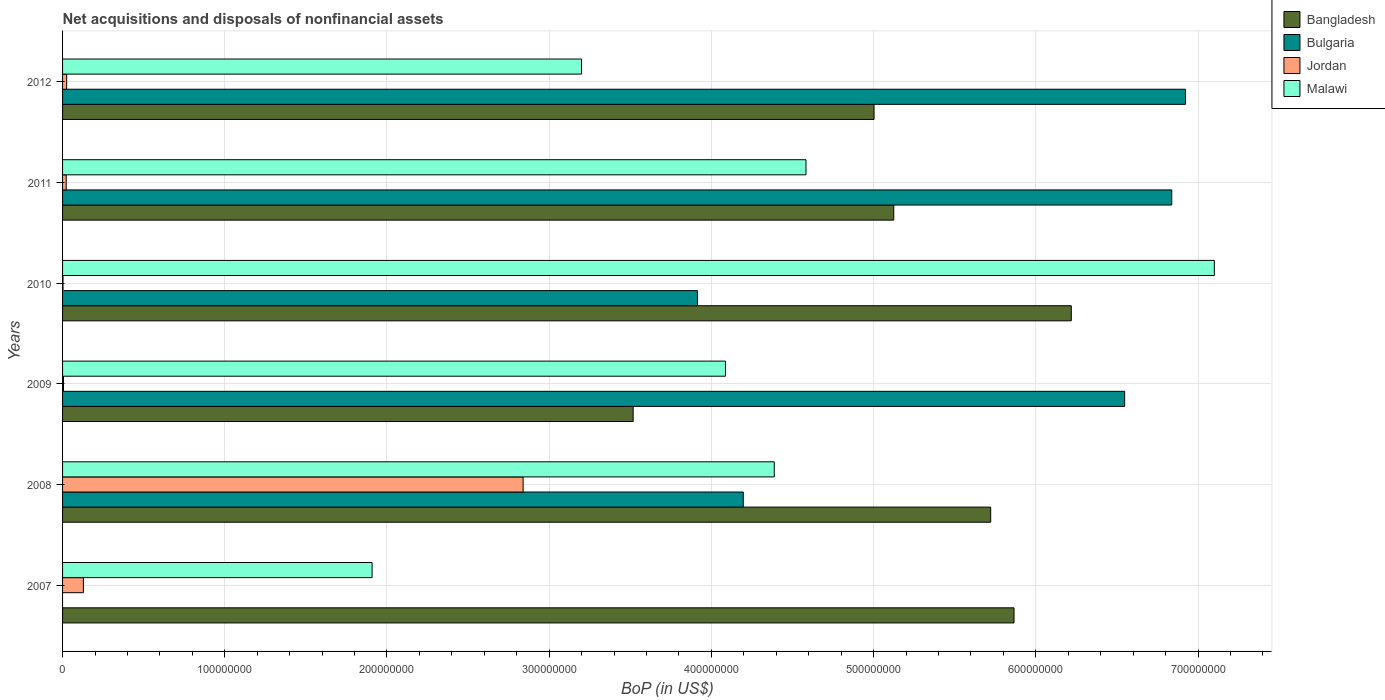How many groups of bars are there?
Your answer should be compact. 6. Are the number of bars per tick equal to the number of legend labels?
Make the answer very short. No. How many bars are there on the 3rd tick from the bottom?
Provide a short and direct response. 4. What is the label of the 5th group of bars from the top?
Offer a terse response. 2008. What is the Balance of Payments in Jordan in 2011?
Provide a short and direct response. 2.25e+06. Across all years, what is the maximum Balance of Payments in Jordan?
Your answer should be compact. 2.84e+08. Across all years, what is the minimum Balance of Payments in Bangladesh?
Your answer should be very brief. 3.52e+08. What is the total Balance of Payments in Bangladesh in the graph?
Your response must be concise. 3.15e+09. What is the difference between the Balance of Payments in Jordan in 2007 and that in 2012?
Offer a terse response. 1.03e+07. What is the difference between the Balance of Payments in Malawi in 2010 and the Balance of Payments in Jordan in 2008?
Provide a short and direct response. 4.26e+08. What is the average Balance of Payments in Bangladesh per year?
Your answer should be compact. 5.24e+08. In the year 2011, what is the difference between the Balance of Payments in Malawi and Balance of Payments in Bangladesh?
Ensure brevity in your answer.  -5.41e+07. What is the ratio of the Balance of Payments in Malawi in 2007 to that in 2011?
Offer a very short reply. 0.42. Is the difference between the Balance of Payments in Malawi in 2007 and 2008 greater than the difference between the Balance of Payments in Bangladesh in 2007 and 2008?
Ensure brevity in your answer.  No. What is the difference between the highest and the second highest Balance of Payments in Malawi?
Make the answer very short. 2.52e+08. What is the difference between the highest and the lowest Balance of Payments in Bulgaria?
Make the answer very short. 6.92e+08. Is it the case that in every year, the sum of the Balance of Payments in Bulgaria and Balance of Payments in Malawi is greater than the Balance of Payments in Jordan?
Make the answer very short. Yes. How many bars are there?
Ensure brevity in your answer.  23. What is the difference between two consecutive major ticks on the X-axis?
Provide a short and direct response. 1.00e+08. Does the graph contain any zero values?
Keep it short and to the point. Yes. Does the graph contain grids?
Make the answer very short. Yes. Where does the legend appear in the graph?
Make the answer very short. Top right. How are the legend labels stacked?
Make the answer very short. Vertical. What is the title of the graph?
Offer a terse response. Net acquisitions and disposals of nonfinancial assets. Does "Slovenia" appear as one of the legend labels in the graph?
Your response must be concise. No. What is the label or title of the X-axis?
Keep it short and to the point. BoP (in US$). What is the BoP (in US$) of Bangladesh in 2007?
Offer a very short reply. 5.87e+08. What is the BoP (in US$) of Jordan in 2007?
Your answer should be compact. 1.28e+07. What is the BoP (in US$) in Malawi in 2007?
Make the answer very short. 1.91e+08. What is the BoP (in US$) of Bangladesh in 2008?
Your answer should be compact. 5.72e+08. What is the BoP (in US$) in Bulgaria in 2008?
Your answer should be very brief. 4.20e+08. What is the BoP (in US$) of Jordan in 2008?
Your response must be concise. 2.84e+08. What is the BoP (in US$) of Malawi in 2008?
Your answer should be very brief. 4.39e+08. What is the BoP (in US$) in Bangladesh in 2009?
Ensure brevity in your answer.  3.52e+08. What is the BoP (in US$) of Bulgaria in 2009?
Make the answer very short. 6.55e+08. What is the BoP (in US$) of Jordan in 2009?
Make the answer very short. 5.63e+05. What is the BoP (in US$) of Malawi in 2009?
Keep it short and to the point. 4.09e+08. What is the BoP (in US$) of Bangladesh in 2010?
Your answer should be compact. 6.22e+08. What is the BoP (in US$) in Bulgaria in 2010?
Your response must be concise. 3.91e+08. What is the BoP (in US$) in Jordan in 2010?
Provide a succinct answer. 2.82e+05. What is the BoP (in US$) in Malawi in 2010?
Keep it short and to the point. 7.10e+08. What is the BoP (in US$) in Bangladesh in 2011?
Keep it short and to the point. 5.12e+08. What is the BoP (in US$) of Bulgaria in 2011?
Your answer should be compact. 6.84e+08. What is the BoP (in US$) of Jordan in 2011?
Give a very brief answer. 2.25e+06. What is the BoP (in US$) in Malawi in 2011?
Provide a succinct answer. 4.58e+08. What is the BoP (in US$) of Bangladesh in 2012?
Your answer should be compact. 5.00e+08. What is the BoP (in US$) of Bulgaria in 2012?
Your answer should be compact. 6.92e+08. What is the BoP (in US$) of Jordan in 2012?
Offer a terse response. 2.54e+06. What is the BoP (in US$) of Malawi in 2012?
Make the answer very short. 3.20e+08. Across all years, what is the maximum BoP (in US$) of Bangladesh?
Make the answer very short. 6.22e+08. Across all years, what is the maximum BoP (in US$) in Bulgaria?
Your answer should be very brief. 6.92e+08. Across all years, what is the maximum BoP (in US$) in Jordan?
Offer a terse response. 2.84e+08. Across all years, what is the maximum BoP (in US$) of Malawi?
Offer a terse response. 7.10e+08. Across all years, what is the minimum BoP (in US$) of Bangladesh?
Ensure brevity in your answer.  3.52e+08. Across all years, what is the minimum BoP (in US$) in Bulgaria?
Your answer should be compact. 0. Across all years, what is the minimum BoP (in US$) of Jordan?
Your answer should be compact. 2.82e+05. Across all years, what is the minimum BoP (in US$) in Malawi?
Give a very brief answer. 1.91e+08. What is the total BoP (in US$) of Bangladesh in the graph?
Keep it short and to the point. 3.15e+09. What is the total BoP (in US$) of Bulgaria in the graph?
Your answer should be compact. 2.84e+09. What is the total BoP (in US$) in Jordan in the graph?
Ensure brevity in your answer.  3.02e+08. What is the total BoP (in US$) in Malawi in the graph?
Provide a succinct answer. 2.53e+09. What is the difference between the BoP (in US$) of Bangladesh in 2007 and that in 2008?
Provide a short and direct response. 1.44e+07. What is the difference between the BoP (in US$) in Jordan in 2007 and that in 2008?
Ensure brevity in your answer.  -2.71e+08. What is the difference between the BoP (in US$) in Malawi in 2007 and that in 2008?
Offer a terse response. -2.48e+08. What is the difference between the BoP (in US$) of Bangladesh in 2007 and that in 2009?
Make the answer very short. 2.35e+08. What is the difference between the BoP (in US$) of Jordan in 2007 and that in 2009?
Provide a succinct answer. 1.23e+07. What is the difference between the BoP (in US$) in Malawi in 2007 and that in 2009?
Provide a short and direct response. -2.18e+08. What is the difference between the BoP (in US$) of Bangladesh in 2007 and that in 2010?
Provide a succinct answer. -3.53e+07. What is the difference between the BoP (in US$) in Jordan in 2007 and that in 2010?
Your answer should be compact. 1.26e+07. What is the difference between the BoP (in US$) of Malawi in 2007 and that in 2010?
Provide a succinct answer. -5.19e+08. What is the difference between the BoP (in US$) of Bangladesh in 2007 and that in 2011?
Provide a short and direct response. 7.41e+07. What is the difference between the BoP (in US$) of Jordan in 2007 and that in 2011?
Keep it short and to the point. 1.06e+07. What is the difference between the BoP (in US$) of Malawi in 2007 and that in 2011?
Your answer should be compact. -2.67e+08. What is the difference between the BoP (in US$) of Bangladesh in 2007 and that in 2012?
Keep it short and to the point. 8.63e+07. What is the difference between the BoP (in US$) in Jordan in 2007 and that in 2012?
Your answer should be very brief. 1.03e+07. What is the difference between the BoP (in US$) of Malawi in 2007 and that in 2012?
Offer a terse response. -1.29e+08. What is the difference between the BoP (in US$) of Bangladesh in 2008 and that in 2009?
Your response must be concise. 2.20e+08. What is the difference between the BoP (in US$) of Bulgaria in 2008 and that in 2009?
Keep it short and to the point. -2.35e+08. What is the difference between the BoP (in US$) in Jordan in 2008 and that in 2009?
Make the answer very short. 2.83e+08. What is the difference between the BoP (in US$) of Malawi in 2008 and that in 2009?
Offer a very short reply. 3.01e+07. What is the difference between the BoP (in US$) of Bangladesh in 2008 and that in 2010?
Keep it short and to the point. -4.97e+07. What is the difference between the BoP (in US$) of Bulgaria in 2008 and that in 2010?
Your response must be concise. 2.82e+07. What is the difference between the BoP (in US$) in Jordan in 2008 and that in 2010?
Offer a very short reply. 2.84e+08. What is the difference between the BoP (in US$) in Malawi in 2008 and that in 2010?
Make the answer very short. -2.71e+08. What is the difference between the BoP (in US$) of Bangladesh in 2008 and that in 2011?
Provide a succinct answer. 5.98e+07. What is the difference between the BoP (in US$) in Bulgaria in 2008 and that in 2011?
Offer a terse response. -2.64e+08. What is the difference between the BoP (in US$) of Jordan in 2008 and that in 2011?
Provide a succinct answer. 2.82e+08. What is the difference between the BoP (in US$) of Malawi in 2008 and that in 2011?
Keep it short and to the point. -1.96e+07. What is the difference between the BoP (in US$) in Bangladesh in 2008 and that in 2012?
Your answer should be compact. 7.19e+07. What is the difference between the BoP (in US$) in Bulgaria in 2008 and that in 2012?
Your answer should be very brief. -2.73e+08. What is the difference between the BoP (in US$) of Jordan in 2008 and that in 2012?
Make the answer very short. 2.81e+08. What is the difference between the BoP (in US$) in Malawi in 2008 and that in 2012?
Provide a succinct answer. 1.19e+08. What is the difference between the BoP (in US$) in Bangladesh in 2009 and that in 2010?
Ensure brevity in your answer.  -2.70e+08. What is the difference between the BoP (in US$) of Bulgaria in 2009 and that in 2010?
Ensure brevity in your answer.  2.63e+08. What is the difference between the BoP (in US$) in Jordan in 2009 and that in 2010?
Your answer should be very brief. 2.82e+05. What is the difference between the BoP (in US$) of Malawi in 2009 and that in 2010?
Ensure brevity in your answer.  -3.01e+08. What is the difference between the BoP (in US$) of Bangladesh in 2009 and that in 2011?
Your answer should be compact. -1.61e+08. What is the difference between the BoP (in US$) of Bulgaria in 2009 and that in 2011?
Provide a succinct answer. -2.90e+07. What is the difference between the BoP (in US$) of Jordan in 2009 and that in 2011?
Give a very brief answer. -1.69e+06. What is the difference between the BoP (in US$) of Malawi in 2009 and that in 2011?
Provide a succinct answer. -4.96e+07. What is the difference between the BoP (in US$) of Bangladesh in 2009 and that in 2012?
Your answer should be compact. -1.48e+08. What is the difference between the BoP (in US$) of Bulgaria in 2009 and that in 2012?
Your answer should be very brief. -3.75e+07. What is the difference between the BoP (in US$) in Jordan in 2009 and that in 2012?
Your response must be concise. -1.97e+06. What is the difference between the BoP (in US$) of Malawi in 2009 and that in 2012?
Make the answer very short. 8.88e+07. What is the difference between the BoP (in US$) of Bangladesh in 2010 and that in 2011?
Ensure brevity in your answer.  1.09e+08. What is the difference between the BoP (in US$) in Bulgaria in 2010 and that in 2011?
Give a very brief answer. -2.92e+08. What is the difference between the BoP (in US$) in Jordan in 2010 and that in 2011?
Offer a very short reply. -1.97e+06. What is the difference between the BoP (in US$) of Malawi in 2010 and that in 2011?
Make the answer very short. 2.52e+08. What is the difference between the BoP (in US$) of Bangladesh in 2010 and that in 2012?
Offer a terse response. 1.22e+08. What is the difference between the BoP (in US$) in Bulgaria in 2010 and that in 2012?
Your response must be concise. -3.01e+08. What is the difference between the BoP (in US$) in Jordan in 2010 and that in 2012?
Offer a very short reply. -2.25e+06. What is the difference between the BoP (in US$) of Malawi in 2010 and that in 2012?
Ensure brevity in your answer.  3.90e+08. What is the difference between the BoP (in US$) of Bangladesh in 2011 and that in 2012?
Give a very brief answer. 1.21e+07. What is the difference between the BoP (in US$) of Bulgaria in 2011 and that in 2012?
Provide a short and direct response. -8.50e+06. What is the difference between the BoP (in US$) in Jordan in 2011 and that in 2012?
Ensure brevity in your answer.  -2.82e+05. What is the difference between the BoP (in US$) of Malawi in 2011 and that in 2012?
Give a very brief answer. 1.38e+08. What is the difference between the BoP (in US$) of Bangladesh in 2007 and the BoP (in US$) of Bulgaria in 2008?
Your answer should be very brief. 1.67e+08. What is the difference between the BoP (in US$) of Bangladesh in 2007 and the BoP (in US$) of Jordan in 2008?
Your answer should be very brief. 3.03e+08. What is the difference between the BoP (in US$) in Bangladesh in 2007 and the BoP (in US$) in Malawi in 2008?
Keep it short and to the point. 1.48e+08. What is the difference between the BoP (in US$) of Jordan in 2007 and the BoP (in US$) of Malawi in 2008?
Offer a very short reply. -4.26e+08. What is the difference between the BoP (in US$) in Bangladesh in 2007 and the BoP (in US$) in Bulgaria in 2009?
Provide a short and direct response. -6.82e+07. What is the difference between the BoP (in US$) in Bangladesh in 2007 and the BoP (in US$) in Jordan in 2009?
Your response must be concise. 5.86e+08. What is the difference between the BoP (in US$) of Bangladesh in 2007 and the BoP (in US$) of Malawi in 2009?
Your response must be concise. 1.78e+08. What is the difference between the BoP (in US$) in Jordan in 2007 and the BoP (in US$) in Malawi in 2009?
Your answer should be compact. -3.96e+08. What is the difference between the BoP (in US$) in Bangladesh in 2007 and the BoP (in US$) in Bulgaria in 2010?
Your answer should be compact. 1.95e+08. What is the difference between the BoP (in US$) in Bangladesh in 2007 and the BoP (in US$) in Jordan in 2010?
Offer a very short reply. 5.86e+08. What is the difference between the BoP (in US$) of Bangladesh in 2007 and the BoP (in US$) of Malawi in 2010?
Make the answer very short. -1.23e+08. What is the difference between the BoP (in US$) in Jordan in 2007 and the BoP (in US$) in Malawi in 2010?
Make the answer very short. -6.97e+08. What is the difference between the BoP (in US$) in Bangladesh in 2007 and the BoP (in US$) in Bulgaria in 2011?
Give a very brief answer. -9.72e+07. What is the difference between the BoP (in US$) in Bangladesh in 2007 and the BoP (in US$) in Jordan in 2011?
Keep it short and to the point. 5.84e+08. What is the difference between the BoP (in US$) of Bangladesh in 2007 and the BoP (in US$) of Malawi in 2011?
Offer a terse response. 1.28e+08. What is the difference between the BoP (in US$) in Jordan in 2007 and the BoP (in US$) in Malawi in 2011?
Provide a short and direct response. -4.45e+08. What is the difference between the BoP (in US$) in Bangladesh in 2007 and the BoP (in US$) in Bulgaria in 2012?
Ensure brevity in your answer.  -1.06e+08. What is the difference between the BoP (in US$) of Bangladesh in 2007 and the BoP (in US$) of Jordan in 2012?
Offer a terse response. 5.84e+08. What is the difference between the BoP (in US$) of Bangladesh in 2007 and the BoP (in US$) of Malawi in 2012?
Ensure brevity in your answer.  2.67e+08. What is the difference between the BoP (in US$) of Jordan in 2007 and the BoP (in US$) of Malawi in 2012?
Your answer should be compact. -3.07e+08. What is the difference between the BoP (in US$) in Bangladesh in 2008 and the BoP (in US$) in Bulgaria in 2009?
Offer a terse response. -8.26e+07. What is the difference between the BoP (in US$) in Bangladesh in 2008 and the BoP (in US$) in Jordan in 2009?
Your answer should be very brief. 5.72e+08. What is the difference between the BoP (in US$) of Bangladesh in 2008 and the BoP (in US$) of Malawi in 2009?
Offer a terse response. 1.63e+08. What is the difference between the BoP (in US$) of Bulgaria in 2008 and the BoP (in US$) of Jordan in 2009?
Offer a very short reply. 4.19e+08. What is the difference between the BoP (in US$) of Bulgaria in 2008 and the BoP (in US$) of Malawi in 2009?
Keep it short and to the point. 1.10e+07. What is the difference between the BoP (in US$) in Jordan in 2008 and the BoP (in US$) in Malawi in 2009?
Your response must be concise. -1.25e+08. What is the difference between the BoP (in US$) in Bangladesh in 2008 and the BoP (in US$) in Bulgaria in 2010?
Give a very brief answer. 1.81e+08. What is the difference between the BoP (in US$) in Bangladesh in 2008 and the BoP (in US$) in Jordan in 2010?
Offer a very short reply. 5.72e+08. What is the difference between the BoP (in US$) in Bangladesh in 2008 and the BoP (in US$) in Malawi in 2010?
Your answer should be compact. -1.38e+08. What is the difference between the BoP (in US$) of Bulgaria in 2008 and the BoP (in US$) of Jordan in 2010?
Keep it short and to the point. 4.19e+08. What is the difference between the BoP (in US$) of Bulgaria in 2008 and the BoP (in US$) of Malawi in 2010?
Your answer should be compact. -2.90e+08. What is the difference between the BoP (in US$) in Jordan in 2008 and the BoP (in US$) in Malawi in 2010?
Your answer should be very brief. -4.26e+08. What is the difference between the BoP (in US$) of Bangladesh in 2008 and the BoP (in US$) of Bulgaria in 2011?
Your answer should be compact. -1.12e+08. What is the difference between the BoP (in US$) in Bangladesh in 2008 and the BoP (in US$) in Jordan in 2011?
Make the answer very short. 5.70e+08. What is the difference between the BoP (in US$) of Bangladesh in 2008 and the BoP (in US$) of Malawi in 2011?
Ensure brevity in your answer.  1.14e+08. What is the difference between the BoP (in US$) of Bulgaria in 2008 and the BoP (in US$) of Jordan in 2011?
Offer a very short reply. 4.17e+08. What is the difference between the BoP (in US$) of Bulgaria in 2008 and the BoP (in US$) of Malawi in 2011?
Ensure brevity in your answer.  -3.87e+07. What is the difference between the BoP (in US$) in Jordan in 2008 and the BoP (in US$) in Malawi in 2011?
Your answer should be very brief. -1.74e+08. What is the difference between the BoP (in US$) in Bangladesh in 2008 and the BoP (in US$) in Bulgaria in 2012?
Offer a very short reply. -1.20e+08. What is the difference between the BoP (in US$) in Bangladesh in 2008 and the BoP (in US$) in Jordan in 2012?
Your answer should be very brief. 5.70e+08. What is the difference between the BoP (in US$) of Bangladesh in 2008 and the BoP (in US$) of Malawi in 2012?
Provide a short and direct response. 2.52e+08. What is the difference between the BoP (in US$) in Bulgaria in 2008 and the BoP (in US$) in Jordan in 2012?
Ensure brevity in your answer.  4.17e+08. What is the difference between the BoP (in US$) in Bulgaria in 2008 and the BoP (in US$) in Malawi in 2012?
Your answer should be very brief. 9.97e+07. What is the difference between the BoP (in US$) of Jordan in 2008 and the BoP (in US$) of Malawi in 2012?
Offer a very short reply. -3.60e+07. What is the difference between the BoP (in US$) in Bangladesh in 2009 and the BoP (in US$) in Bulgaria in 2010?
Offer a very short reply. -3.97e+07. What is the difference between the BoP (in US$) in Bangladesh in 2009 and the BoP (in US$) in Jordan in 2010?
Give a very brief answer. 3.51e+08. What is the difference between the BoP (in US$) of Bangladesh in 2009 and the BoP (in US$) of Malawi in 2010?
Offer a terse response. -3.58e+08. What is the difference between the BoP (in US$) in Bulgaria in 2009 and the BoP (in US$) in Jordan in 2010?
Keep it short and to the point. 6.54e+08. What is the difference between the BoP (in US$) of Bulgaria in 2009 and the BoP (in US$) of Malawi in 2010?
Ensure brevity in your answer.  -5.53e+07. What is the difference between the BoP (in US$) in Jordan in 2009 and the BoP (in US$) in Malawi in 2010?
Offer a terse response. -7.09e+08. What is the difference between the BoP (in US$) in Bangladesh in 2009 and the BoP (in US$) in Bulgaria in 2011?
Your answer should be compact. -3.32e+08. What is the difference between the BoP (in US$) in Bangladesh in 2009 and the BoP (in US$) in Jordan in 2011?
Make the answer very short. 3.50e+08. What is the difference between the BoP (in US$) in Bangladesh in 2009 and the BoP (in US$) in Malawi in 2011?
Your response must be concise. -1.07e+08. What is the difference between the BoP (in US$) in Bulgaria in 2009 and the BoP (in US$) in Jordan in 2011?
Your answer should be compact. 6.53e+08. What is the difference between the BoP (in US$) in Bulgaria in 2009 and the BoP (in US$) in Malawi in 2011?
Give a very brief answer. 1.96e+08. What is the difference between the BoP (in US$) of Jordan in 2009 and the BoP (in US$) of Malawi in 2011?
Your response must be concise. -4.58e+08. What is the difference between the BoP (in US$) in Bangladesh in 2009 and the BoP (in US$) in Bulgaria in 2012?
Your answer should be compact. -3.41e+08. What is the difference between the BoP (in US$) of Bangladesh in 2009 and the BoP (in US$) of Jordan in 2012?
Your answer should be very brief. 3.49e+08. What is the difference between the BoP (in US$) of Bangladesh in 2009 and the BoP (in US$) of Malawi in 2012?
Ensure brevity in your answer.  3.18e+07. What is the difference between the BoP (in US$) in Bulgaria in 2009 and the BoP (in US$) in Jordan in 2012?
Your answer should be compact. 6.52e+08. What is the difference between the BoP (in US$) of Bulgaria in 2009 and the BoP (in US$) of Malawi in 2012?
Provide a short and direct response. 3.35e+08. What is the difference between the BoP (in US$) of Jordan in 2009 and the BoP (in US$) of Malawi in 2012?
Give a very brief answer. -3.19e+08. What is the difference between the BoP (in US$) of Bangladesh in 2010 and the BoP (in US$) of Bulgaria in 2011?
Offer a very short reply. -6.19e+07. What is the difference between the BoP (in US$) of Bangladesh in 2010 and the BoP (in US$) of Jordan in 2011?
Offer a very short reply. 6.20e+08. What is the difference between the BoP (in US$) in Bangladesh in 2010 and the BoP (in US$) in Malawi in 2011?
Keep it short and to the point. 1.64e+08. What is the difference between the BoP (in US$) of Bulgaria in 2010 and the BoP (in US$) of Jordan in 2011?
Keep it short and to the point. 3.89e+08. What is the difference between the BoP (in US$) of Bulgaria in 2010 and the BoP (in US$) of Malawi in 2011?
Your answer should be compact. -6.69e+07. What is the difference between the BoP (in US$) in Jordan in 2010 and the BoP (in US$) in Malawi in 2011?
Provide a short and direct response. -4.58e+08. What is the difference between the BoP (in US$) in Bangladesh in 2010 and the BoP (in US$) in Bulgaria in 2012?
Offer a terse response. -7.04e+07. What is the difference between the BoP (in US$) of Bangladesh in 2010 and the BoP (in US$) of Jordan in 2012?
Make the answer very short. 6.19e+08. What is the difference between the BoP (in US$) of Bangladesh in 2010 and the BoP (in US$) of Malawi in 2012?
Keep it short and to the point. 3.02e+08. What is the difference between the BoP (in US$) of Bulgaria in 2010 and the BoP (in US$) of Jordan in 2012?
Your answer should be compact. 3.89e+08. What is the difference between the BoP (in US$) in Bulgaria in 2010 and the BoP (in US$) in Malawi in 2012?
Provide a succinct answer. 7.15e+07. What is the difference between the BoP (in US$) in Jordan in 2010 and the BoP (in US$) in Malawi in 2012?
Ensure brevity in your answer.  -3.20e+08. What is the difference between the BoP (in US$) of Bangladesh in 2011 and the BoP (in US$) of Bulgaria in 2012?
Give a very brief answer. -1.80e+08. What is the difference between the BoP (in US$) of Bangladesh in 2011 and the BoP (in US$) of Jordan in 2012?
Provide a succinct answer. 5.10e+08. What is the difference between the BoP (in US$) of Bangladesh in 2011 and the BoP (in US$) of Malawi in 2012?
Give a very brief answer. 1.92e+08. What is the difference between the BoP (in US$) of Bulgaria in 2011 and the BoP (in US$) of Jordan in 2012?
Your answer should be very brief. 6.81e+08. What is the difference between the BoP (in US$) in Bulgaria in 2011 and the BoP (in US$) in Malawi in 2012?
Your response must be concise. 3.64e+08. What is the difference between the BoP (in US$) of Jordan in 2011 and the BoP (in US$) of Malawi in 2012?
Provide a succinct answer. -3.18e+08. What is the average BoP (in US$) of Bangladesh per year?
Ensure brevity in your answer.  5.24e+08. What is the average BoP (in US$) in Bulgaria per year?
Provide a short and direct response. 4.74e+08. What is the average BoP (in US$) in Jordan per year?
Ensure brevity in your answer.  5.04e+07. What is the average BoP (in US$) of Malawi per year?
Provide a short and direct response. 4.21e+08. In the year 2007, what is the difference between the BoP (in US$) of Bangladesh and BoP (in US$) of Jordan?
Ensure brevity in your answer.  5.74e+08. In the year 2007, what is the difference between the BoP (in US$) of Bangladesh and BoP (in US$) of Malawi?
Your answer should be compact. 3.96e+08. In the year 2007, what is the difference between the BoP (in US$) of Jordan and BoP (in US$) of Malawi?
Your answer should be compact. -1.78e+08. In the year 2008, what is the difference between the BoP (in US$) of Bangladesh and BoP (in US$) of Bulgaria?
Make the answer very short. 1.53e+08. In the year 2008, what is the difference between the BoP (in US$) of Bangladesh and BoP (in US$) of Jordan?
Ensure brevity in your answer.  2.88e+08. In the year 2008, what is the difference between the BoP (in US$) in Bangladesh and BoP (in US$) in Malawi?
Your answer should be compact. 1.33e+08. In the year 2008, what is the difference between the BoP (in US$) in Bulgaria and BoP (in US$) in Jordan?
Provide a succinct answer. 1.36e+08. In the year 2008, what is the difference between the BoP (in US$) of Bulgaria and BoP (in US$) of Malawi?
Your answer should be compact. -1.91e+07. In the year 2008, what is the difference between the BoP (in US$) of Jordan and BoP (in US$) of Malawi?
Ensure brevity in your answer.  -1.55e+08. In the year 2009, what is the difference between the BoP (in US$) of Bangladesh and BoP (in US$) of Bulgaria?
Your answer should be compact. -3.03e+08. In the year 2009, what is the difference between the BoP (in US$) in Bangladesh and BoP (in US$) in Jordan?
Give a very brief answer. 3.51e+08. In the year 2009, what is the difference between the BoP (in US$) of Bangladesh and BoP (in US$) of Malawi?
Offer a very short reply. -5.69e+07. In the year 2009, what is the difference between the BoP (in US$) of Bulgaria and BoP (in US$) of Jordan?
Ensure brevity in your answer.  6.54e+08. In the year 2009, what is the difference between the BoP (in US$) of Bulgaria and BoP (in US$) of Malawi?
Make the answer very short. 2.46e+08. In the year 2009, what is the difference between the BoP (in US$) of Jordan and BoP (in US$) of Malawi?
Offer a very short reply. -4.08e+08. In the year 2010, what is the difference between the BoP (in US$) in Bangladesh and BoP (in US$) in Bulgaria?
Your answer should be compact. 2.30e+08. In the year 2010, what is the difference between the BoP (in US$) of Bangladesh and BoP (in US$) of Jordan?
Make the answer very short. 6.22e+08. In the year 2010, what is the difference between the BoP (in US$) of Bangladesh and BoP (in US$) of Malawi?
Keep it short and to the point. -8.82e+07. In the year 2010, what is the difference between the BoP (in US$) of Bulgaria and BoP (in US$) of Jordan?
Your answer should be compact. 3.91e+08. In the year 2010, what is the difference between the BoP (in US$) of Bulgaria and BoP (in US$) of Malawi?
Give a very brief answer. -3.19e+08. In the year 2010, what is the difference between the BoP (in US$) in Jordan and BoP (in US$) in Malawi?
Provide a succinct answer. -7.10e+08. In the year 2011, what is the difference between the BoP (in US$) of Bangladesh and BoP (in US$) of Bulgaria?
Your response must be concise. -1.71e+08. In the year 2011, what is the difference between the BoP (in US$) in Bangladesh and BoP (in US$) in Jordan?
Your response must be concise. 5.10e+08. In the year 2011, what is the difference between the BoP (in US$) in Bangladesh and BoP (in US$) in Malawi?
Give a very brief answer. 5.41e+07. In the year 2011, what is the difference between the BoP (in US$) of Bulgaria and BoP (in US$) of Jordan?
Your answer should be very brief. 6.82e+08. In the year 2011, what is the difference between the BoP (in US$) of Bulgaria and BoP (in US$) of Malawi?
Ensure brevity in your answer.  2.25e+08. In the year 2011, what is the difference between the BoP (in US$) of Jordan and BoP (in US$) of Malawi?
Provide a short and direct response. -4.56e+08. In the year 2012, what is the difference between the BoP (in US$) in Bangladesh and BoP (in US$) in Bulgaria?
Provide a succinct answer. -1.92e+08. In the year 2012, what is the difference between the BoP (in US$) of Bangladesh and BoP (in US$) of Jordan?
Your response must be concise. 4.98e+08. In the year 2012, what is the difference between the BoP (in US$) of Bangladesh and BoP (in US$) of Malawi?
Offer a very short reply. 1.80e+08. In the year 2012, what is the difference between the BoP (in US$) in Bulgaria and BoP (in US$) in Jordan?
Keep it short and to the point. 6.90e+08. In the year 2012, what is the difference between the BoP (in US$) of Bulgaria and BoP (in US$) of Malawi?
Make the answer very short. 3.72e+08. In the year 2012, what is the difference between the BoP (in US$) in Jordan and BoP (in US$) in Malawi?
Keep it short and to the point. -3.17e+08. What is the ratio of the BoP (in US$) of Bangladesh in 2007 to that in 2008?
Offer a very short reply. 1.03. What is the ratio of the BoP (in US$) in Jordan in 2007 to that in 2008?
Your response must be concise. 0.05. What is the ratio of the BoP (in US$) of Malawi in 2007 to that in 2008?
Give a very brief answer. 0.43. What is the ratio of the BoP (in US$) in Bangladesh in 2007 to that in 2009?
Your answer should be very brief. 1.67. What is the ratio of the BoP (in US$) of Jordan in 2007 to that in 2009?
Make the answer very short. 22.78. What is the ratio of the BoP (in US$) of Malawi in 2007 to that in 2009?
Your answer should be compact. 0.47. What is the ratio of the BoP (in US$) in Bangladesh in 2007 to that in 2010?
Ensure brevity in your answer.  0.94. What is the ratio of the BoP (in US$) in Jordan in 2007 to that in 2010?
Your response must be concise. 45.56. What is the ratio of the BoP (in US$) in Malawi in 2007 to that in 2010?
Provide a succinct answer. 0.27. What is the ratio of the BoP (in US$) of Bangladesh in 2007 to that in 2011?
Make the answer very short. 1.14. What is the ratio of the BoP (in US$) in Jordan in 2007 to that in 2011?
Provide a succinct answer. 5.7. What is the ratio of the BoP (in US$) of Malawi in 2007 to that in 2011?
Provide a succinct answer. 0.42. What is the ratio of the BoP (in US$) of Bangladesh in 2007 to that in 2012?
Keep it short and to the point. 1.17. What is the ratio of the BoP (in US$) of Jordan in 2007 to that in 2012?
Offer a terse response. 5.06. What is the ratio of the BoP (in US$) in Malawi in 2007 to that in 2012?
Make the answer very short. 0.6. What is the ratio of the BoP (in US$) of Bangladesh in 2008 to that in 2009?
Your response must be concise. 1.63. What is the ratio of the BoP (in US$) of Bulgaria in 2008 to that in 2009?
Offer a terse response. 0.64. What is the ratio of the BoP (in US$) in Jordan in 2008 to that in 2009?
Provide a short and direct response. 503.95. What is the ratio of the BoP (in US$) in Malawi in 2008 to that in 2009?
Provide a short and direct response. 1.07. What is the ratio of the BoP (in US$) in Bangladesh in 2008 to that in 2010?
Offer a terse response. 0.92. What is the ratio of the BoP (in US$) in Bulgaria in 2008 to that in 2010?
Ensure brevity in your answer.  1.07. What is the ratio of the BoP (in US$) in Jordan in 2008 to that in 2010?
Your response must be concise. 1007.9. What is the ratio of the BoP (in US$) in Malawi in 2008 to that in 2010?
Offer a terse response. 0.62. What is the ratio of the BoP (in US$) of Bangladesh in 2008 to that in 2011?
Your answer should be very brief. 1.12. What is the ratio of the BoP (in US$) of Bulgaria in 2008 to that in 2011?
Give a very brief answer. 0.61. What is the ratio of the BoP (in US$) of Jordan in 2008 to that in 2011?
Ensure brevity in your answer.  125.99. What is the ratio of the BoP (in US$) of Malawi in 2008 to that in 2011?
Provide a succinct answer. 0.96. What is the ratio of the BoP (in US$) of Bangladesh in 2008 to that in 2012?
Your response must be concise. 1.14. What is the ratio of the BoP (in US$) of Bulgaria in 2008 to that in 2012?
Give a very brief answer. 0.61. What is the ratio of the BoP (in US$) in Jordan in 2008 to that in 2012?
Your response must be concise. 111.99. What is the ratio of the BoP (in US$) in Malawi in 2008 to that in 2012?
Your answer should be compact. 1.37. What is the ratio of the BoP (in US$) in Bangladesh in 2009 to that in 2010?
Your answer should be very brief. 0.57. What is the ratio of the BoP (in US$) in Bulgaria in 2009 to that in 2010?
Your answer should be very brief. 1.67. What is the ratio of the BoP (in US$) of Malawi in 2009 to that in 2010?
Offer a terse response. 0.58. What is the ratio of the BoP (in US$) of Bangladesh in 2009 to that in 2011?
Offer a very short reply. 0.69. What is the ratio of the BoP (in US$) of Bulgaria in 2009 to that in 2011?
Offer a terse response. 0.96. What is the ratio of the BoP (in US$) of Malawi in 2009 to that in 2011?
Ensure brevity in your answer.  0.89. What is the ratio of the BoP (in US$) in Bangladesh in 2009 to that in 2012?
Offer a very short reply. 0.7. What is the ratio of the BoP (in US$) of Bulgaria in 2009 to that in 2012?
Your response must be concise. 0.95. What is the ratio of the BoP (in US$) of Jordan in 2009 to that in 2012?
Make the answer very short. 0.22. What is the ratio of the BoP (in US$) in Malawi in 2009 to that in 2012?
Your answer should be very brief. 1.28. What is the ratio of the BoP (in US$) in Bangladesh in 2010 to that in 2011?
Provide a succinct answer. 1.21. What is the ratio of the BoP (in US$) of Bulgaria in 2010 to that in 2011?
Offer a terse response. 0.57. What is the ratio of the BoP (in US$) in Malawi in 2010 to that in 2011?
Your answer should be very brief. 1.55. What is the ratio of the BoP (in US$) in Bangladesh in 2010 to that in 2012?
Offer a terse response. 1.24. What is the ratio of the BoP (in US$) in Bulgaria in 2010 to that in 2012?
Make the answer very short. 0.57. What is the ratio of the BoP (in US$) in Jordan in 2010 to that in 2012?
Provide a succinct answer. 0.11. What is the ratio of the BoP (in US$) in Malawi in 2010 to that in 2012?
Provide a short and direct response. 2.22. What is the ratio of the BoP (in US$) of Bangladesh in 2011 to that in 2012?
Your answer should be very brief. 1.02. What is the ratio of the BoP (in US$) in Malawi in 2011 to that in 2012?
Provide a short and direct response. 1.43. What is the difference between the highest and the second highest BoP (in US$) of Bangladesh?
Provide a short and direct response. 3.53e+07. What is the difference between the highest and the second highest BoP (in US$) in Bulgaria?
Keep it short and to the point. 8.50e+06. What is the difference between the highest and the second highest BoP (in US$) in Jordan?
Offer a very short reply. 2.71e+08. What is the difference between the highest and the second highest BoP (in US$) of Malawi?
Offer a terse response. 2.52e+08. What is the difference between the highest and the lowest BoP (in US$) in Bangladesh?
Your response must be concise. 2.70e+08. What is the difference between the highest and the lowest BoP (in US$) in Bulgaria?
Your response must be concise. 6.92e+08. What is the difference between the highest and the lowest BoP (in US$) of Jordan?
Your response must be concise. 2.84e+08. What is the difference between the highest and the lowest BoP (in US$) of Malawi?
Offer a terse response. 5.19e+08. 